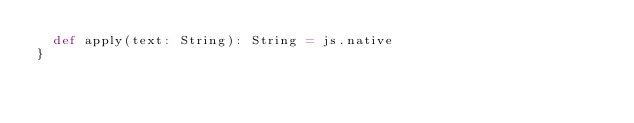<code> <loc_0><loc_0><loc_500><loc_500><_Scala_>  def apply(text: String): String = js.native
}
</code> 